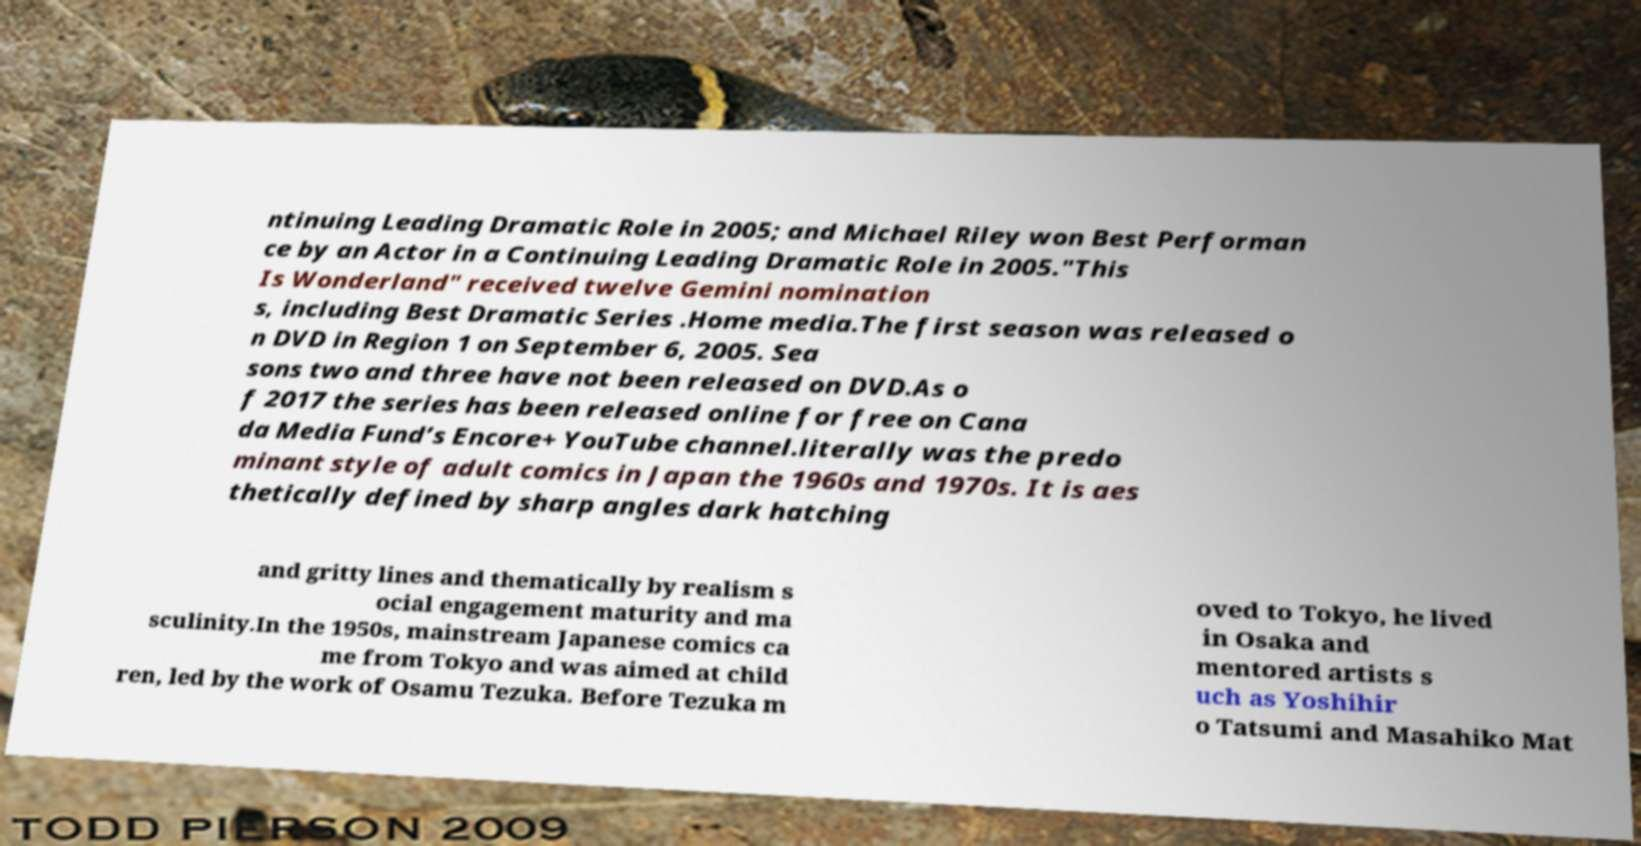I need the written content from this picture converted into text. Can you do that? ntinuing Leading Dramatic Role in 2005; and Michael Riley won Best Performan ce by an Actor in a Continuing Leading Dramatic Role in 2005."This Is Wonderland" received twelve Gemini nomination s, including Best Dramatic Series .Home media.The first season was released o n DVD in Region 1 on September 6, 2005. Sea sons two and three have not been released on DVD.As o f 2017 the series has been released online for free on Cana da Media Fund’s Encore+ YouTube channel.literally was the predo minant style of adult comics in Japan the 1960s and 1970s. It is aes thetically defined by sharp angles dark hatching and gritty lines and thematically by realism s ocial engagement maturity and ma sculinity.In the 1950s, mainstream Japanese comics ca me from Tokyo and was aimed at child ren, led by the work of Osamu Tezuka. Before Tezuka m oved to Tokyo, he lived in Osaka and mentored artists s uch as Yoshihir o Tatsumi and Masahiko Mat 